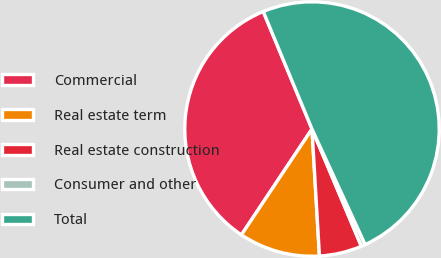Convert chart to OTSL. <chart><loc_0><loc_0><loc_500><loc_500><pie_chart><fcel>Commercial<fcel>Real estate term<fcel>Real estate construction<fcel>Consumer and other<fcel>Total<nl><fcel>34.38%<fcel>10.29%<fcel>5.41%<fcel>0.52%<fcel>49.39%<nl></chart> 